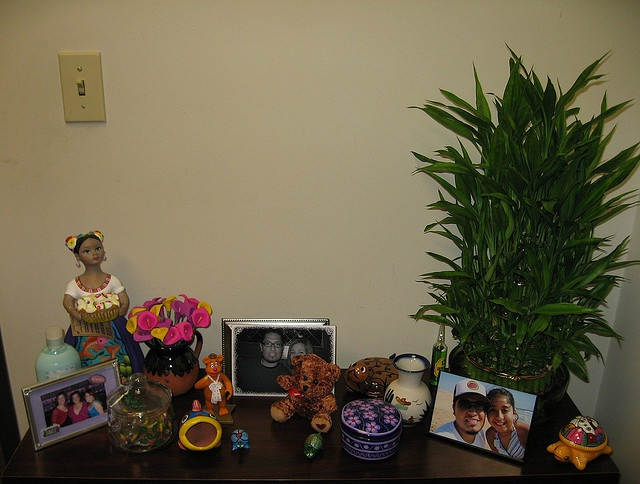Describe the objects in this image and their specific colors. I can see potted plant in olive, black, gray, and darkgreen tones, vase in olive, black, maroon, and gray tones, teddy bear in olive, maroon, black, and brown tones, vase in olive, black, and darkgreen tones, and vase in olive, black, maroon, and gray tones in this image. 